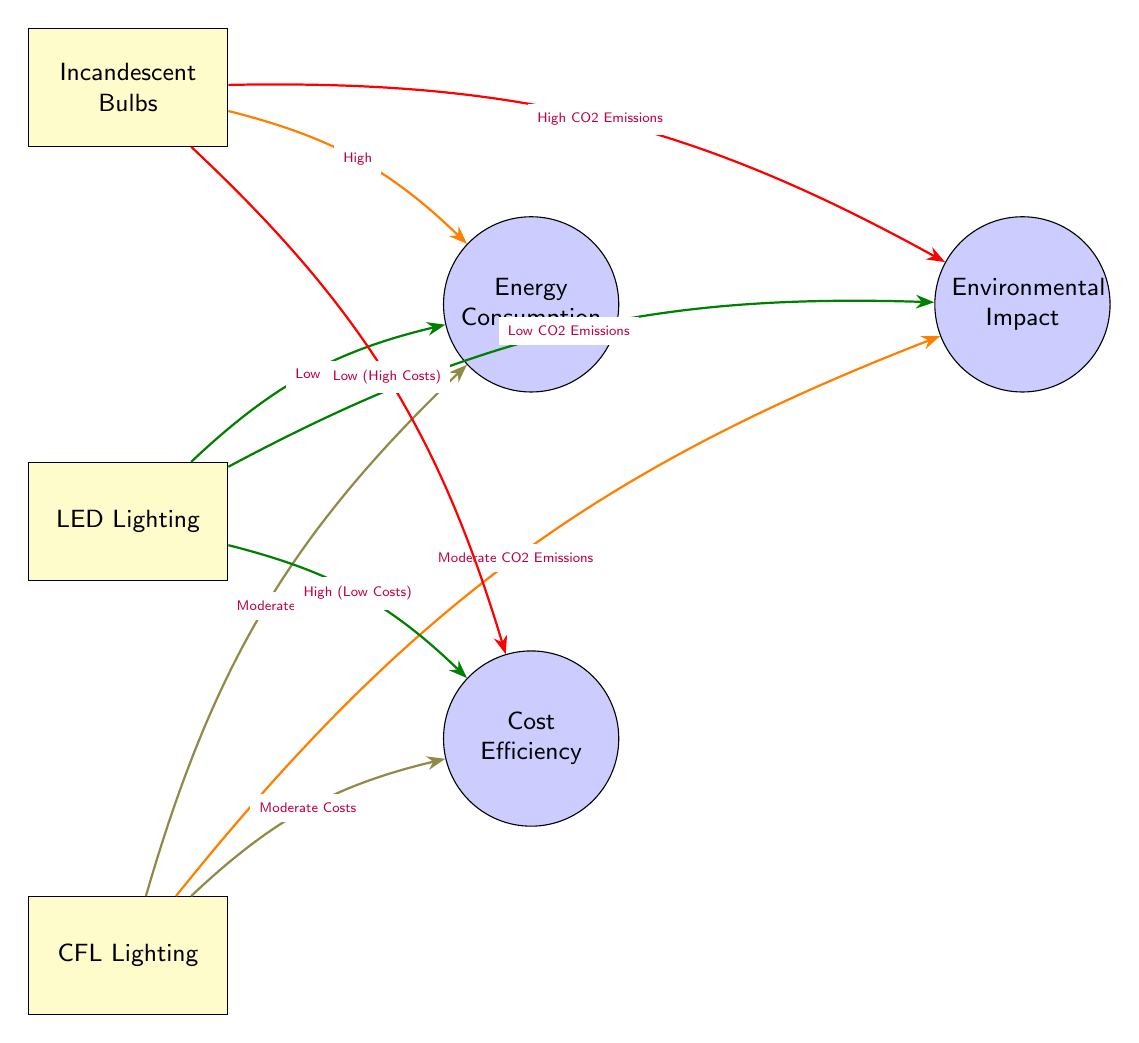What lighting solution has the highest energy consumption? The diagram indicates that Incandescent Bulbs have a "High" energy consumption label connected to them.
Answer: Incandescent Bulbs Which lighting option has the lowest environmental impact? LED Lighting is connected to the Environmental Impact node with a label indicating "Low CO2 Emissions."
Answer: LED Lighting How many lighting solutions are represented in the diagram? The diagram shows three lighting solutions: Incandescent Bulbs, LED Lighting, and CFL Lighting. Therefore, the total count is three.
Answer: 3 What is the cost efficiency status of CFL Lighting? The diagram connects CFL Lighting to the Cost Efficiency node with an indication of "Moderate Costs."
Answer: Moderate Costs If someone wants the most cost-efficient lighting solution, which should they choose? LED Lighting is linked to the Cost Efficiency node with "High (Low Costs)," indicating it is the most cost-efficient option based on the diagram's flow.
Answer: LED Lighting Which lighting solution has moderate CO2 emissions? The diagram shows CFL Lighting connected to the Environmental Impact node with the label "Moderate CO2 Emissions."
Answer: CFL Lighting What type of diagram is used to represent the energy consumption patterns? The diagram is classified as a Natural Science Diagram, as it illustrates relationships between lighting solutions and their respective energy consumption, environmental impact, and cost efficiency.
Answer: Natural Science Diagram What is the relationship between Incandescent Bulbs and Environmental Impact? Incandescent Bulbs lead to the Environmental Impact node with a label indicating "High CO2 Emissions," demonstrating their significant negative impact on the environment.
Answer: High CO2 Emissions Which light source has low energy consumption? LED Lighting is connected to the Energy Consumption node with a label reading "Low," differentiating it from the other solutions.
Answer: LED Lighting 